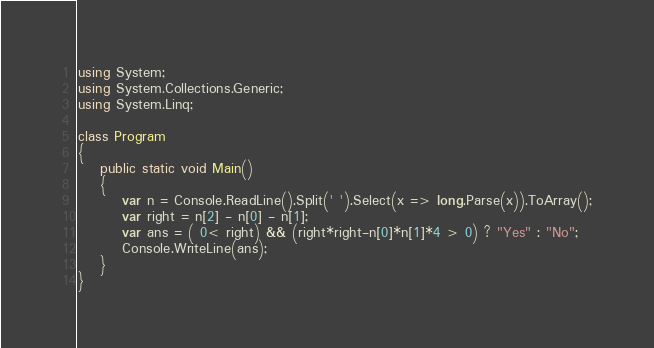Convert code to text. <code><loc_0><loc_0><loc_500><loc_500><_C#_>using System;
using System.Collections.Generic;
using System.Linq;

class Program
{
    public static void Main()
    {
        var n = Console.ReadLine().Split(' ').Select(x => long.Parse(x)).ToArray();
        var right = n[2] - n[0] - n[1];
        var ans = ( 0< right) && (right*right-n[0]*n[1]*4 > 0) ? "Yes" : "No";
        Console.WriteLine(ans);
    }
}
</code> 